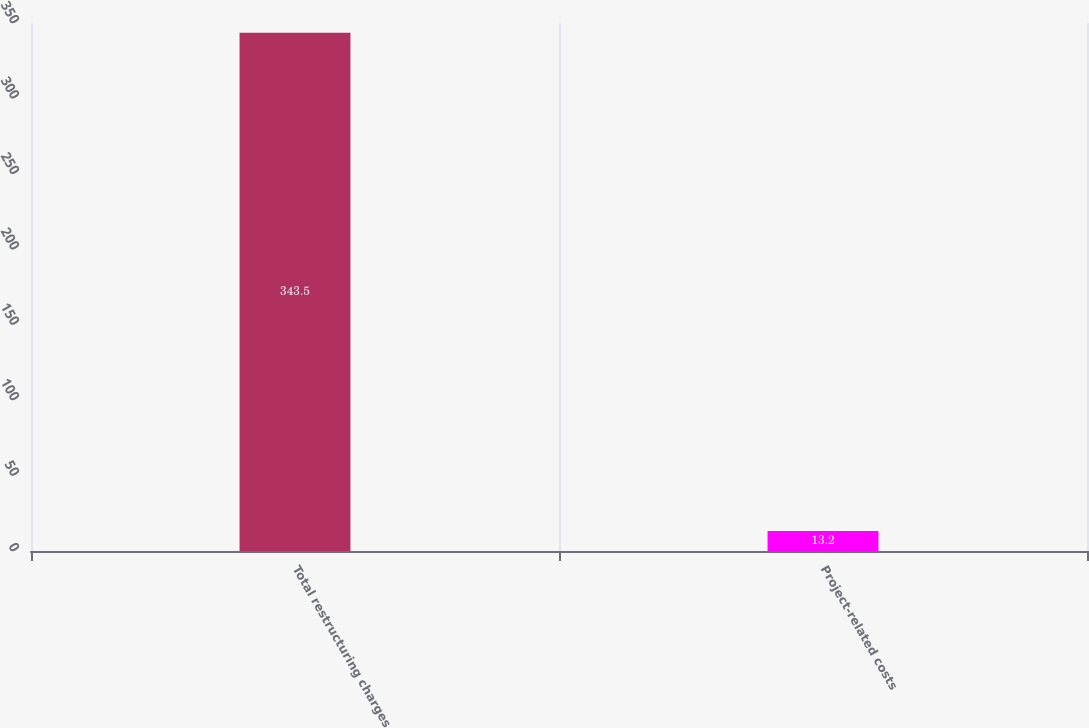<chart> <loc_0><loc_0><loc_500><loc_500><bar_chart><fcel>Total restructuring charges<fcel>Project-related costs<nl><fcel>343.5<fcel>13.2<nl></chart> 